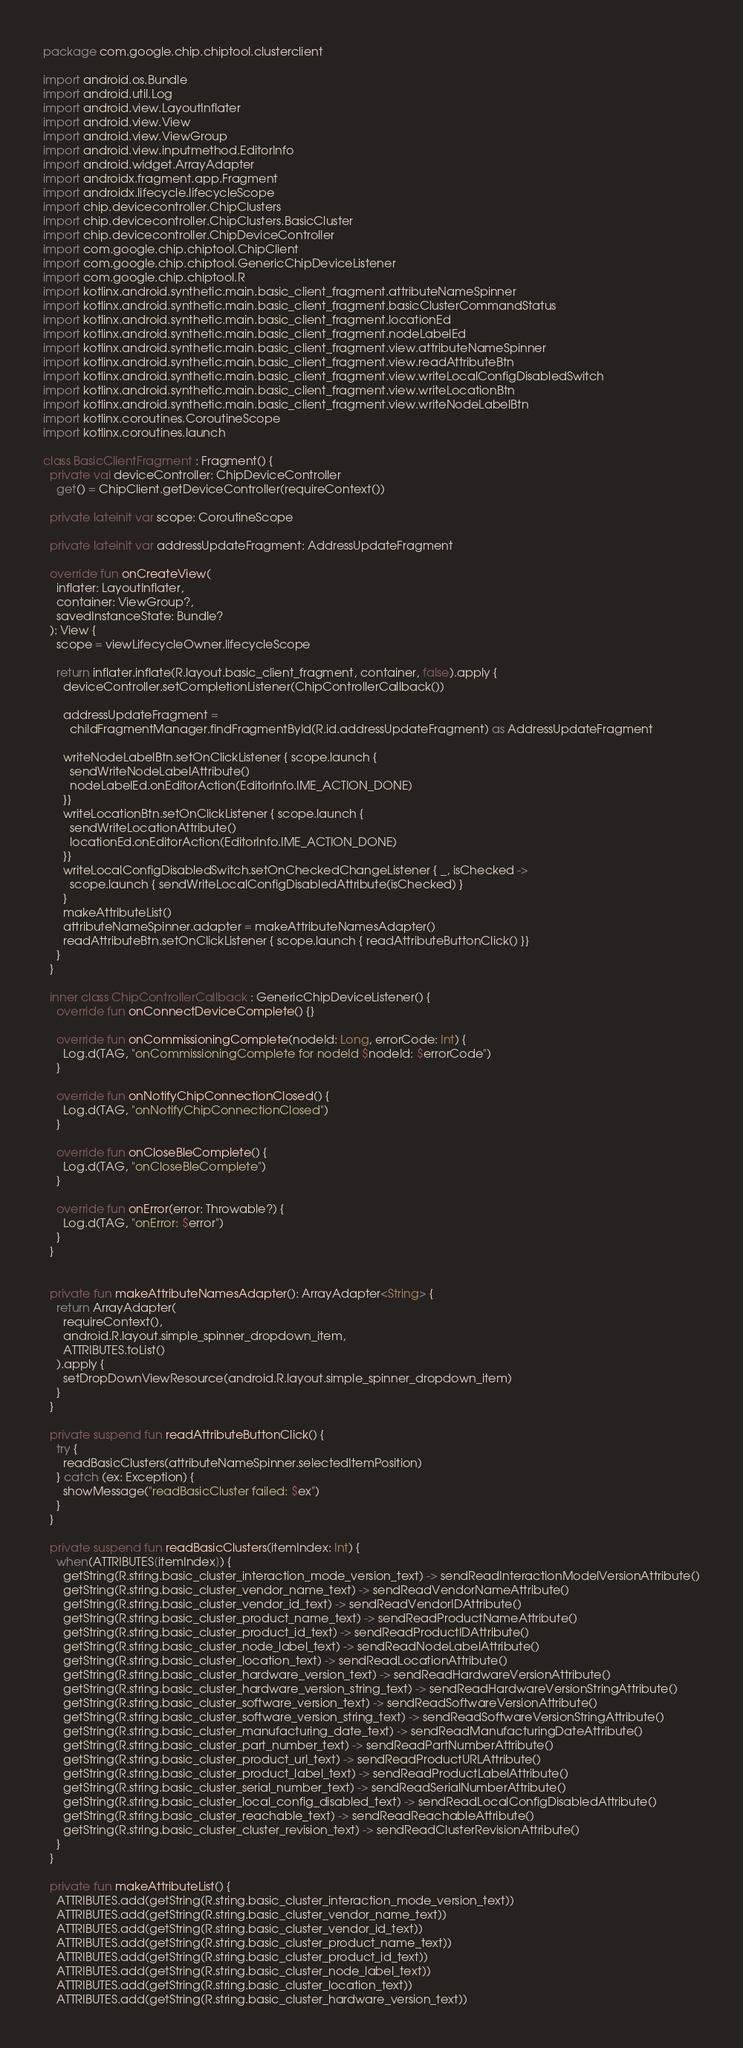<code> <loc_0><loc_0><loc_500><loc_500><_Kotlin_>package com.google.chip.chiptool.clusterclient

import android.os.Bundle
import android.util.Log
import android.view.LayoutInflater
import android.view.View
import android.view.ViewGroup
import android.view.inputmethod.EditorInfo
import android.widget.ArrayAdapter
import androidx.fragment.app.Fragment
import androidx.lifecycle.lifecycleScope
import chip.devicecontroller.ChipClusters
import chip.devicecontroller.ChipClusters.BasicCluster
import chip.devicecontroller.ChipDeviceController
import com.google.chip.chiptool.ChipClient
import com.google.chip.chiptool.GenericChipDeviceListener
import com.google.chip.chiptool.R
import kotlinx.android.synthetic.main.basic_client_fragment.attributeNameSpinner
import kotlinx.android.synthetic.main.basic_client_fragment.basicClusterCommandStatus
import kotlinx.android.synthetic.main.basic_client_fragment.locationEd
import kotlinx.android.synthetic.main.basic_client_fragment.nodeLabelEd
import kotlinx.android.synthetic.main.basic_client_fragment.view.attributeNameSpinner
import kotlinx.android.synthetic.main.basic_client_fragment.view.readAttributeBtn
import kotlinx.android.synthetic.main.basic_client_fragment.view.writeLocalConfigDisabledSwitch
import kotlinx.android.synthetic.main.basic_client_fragment.view.writeLocationBtn
import kotlinx.android.synthetic.main.basic_client_fragment.view.writeNodeLabelBtn
import kotlinx.coroutines.CoroutineScope
import kotlinx.coroutines.launch

class BasicClientFragment : Fragment() {
  private val deviceController: ChipDeviceController
    get() = ChipClient.getDeviceController(requireContext())

  private lateinit var scope: CoroutineScope

  private lateinit var addressUpdateFragment: AddressUpdateFragment

  override fun onCreateView(
    inflater: LayoutInflater,
    container: ViewGroup?,
    savedInstanceState: Bundle?
  ): View {
    scope = viewLifecycleOwner.lifecycleScope

    return inflater.inflate(R.layout.basic_client_fragment, container, false).apply {
      deviceController.setCompletionListener(ChipControllerCallback())

      addressUpdateFragment =
        childFragmentManager.findFragmentById(R.id.addressUpdateFragment) as AddressUpdateFragment

      writeNodeLabelBtn.setOnClickListener { scope.launch {
        sendWriteNodeLabelAttribute()
        nodeLabelEd.onEditorAction(EditorInfo.IME_ACTION_DONE)
      }}
      writeLocationBtn.setOnClickListener { scope.launch {
        sendWriteLocationAttribute()
        locationEd.onEditorAction(EditorInfo.IME_ACTION_DONE)
      }}
      writeLocalConfigDisabledSwitch.setOnCheckedChangeListener { _, isChecked ->
        scope.launch { sendWriteLocalConfigDisabledAttribute(isChecked) }
      }
      makeAttributeList()
      attributeNameSpinner.adapter = makeAttributeNamesAdapter()
      readAttributeBtn.setOnClickListener { scope.launch { readAttributeButtonClick() }}
    }
  }

  inner class ChipControllerCallback : GenericChipDeviceListener() {
    override fun onConnectDeviceComplete() {}

    override fun onCommissioningComplete(nodeId: Long, errorCode: Int) {
      Log.d(TAG, "onCommissioningComplete for nodeId $nodeId: $errorCode")
    }

    override fun onNotifyChipConnectionClosed() {
      Log.d(TAG, "onNotifyChipConnectionClosed")
    }

    override fun onCloseBleComplete() {
      Log.d(TAG, "onCloseBleComplete")
    }

    override fun onError(error: Throwable?) {
      Log.d(TAG, "onError: $error")
    }
  }


  private fun makeAttributeNamesAdapter(): ArrayAdapter<String> {
    return ArrayAdapter(
      requireContext(),
      android.R.layout.simple_spinner_dropdown_item,
      ATTRIBUTES.toList()
    ).apply {
      setDropDownViewResource(android.R.layout.simple_spinner_dropdown_item)
    }
  }

  private suspend fun readAttributeButtonClick() {
    try {
      readBasicClusters(attributeNameSpinner.selectedItemPosition)
    } catch (ex: Exception) {
      showMessage("readBasicCluster failed: $ex")
    }
  }

  private suspend fun readBasicClusters(itemIndex: Int) {
    when(ATTRIBUTES[itemIndex]) {
      getString(R.string.basic_cluster_interaction_mode_version_text) -> sendReadInteractionModelVersionAttribute()
      getString(R.string.basic_cluster_vendor_name_text) -> sendReadVendorNameAttribute()
      getString(R.string.basic_cluster_vendor_id_text) -> sendReadVendorIDAttribute()
      getString(R.string.basic_cluster_product_name_text) -> sendReadProductNameAttribute()
      getString(R.string.basic_cluster_product_id_text) -> sendReadProductIDAttribute()
      getString(R.string.basic_cluster_node_label_text) -> sendReadNodeLabelAttribute()
      getString(R.string.basic_cluster_location_text) -> sendReadLocationAttribute()
      getString(R.string.basic_cluster_hardware_version_text) -> sendReadHardwareVersionAttribute()
      getString(R.string.basic_cluster_hardware_version_string_text) -> sendReadHardwareVersionStringAttribute()
      getString(R.string.basic_cluster_software_version_text) -> sendReadSoftwareVersionAttribute()
      getString(R.string.basic_cluster_software_version_string_text) -> sendReadSoftwareVersionStringAttribute()
      getString(R.string.basic_cluster_manufacturing_date_text) -> sendReadManufacturingDateAttribute()
      getString(R.string.basic_cluster_part_number_text) -> sendReadPartNumberAttribute()
      getString(R.string.basic_cluster_product_url_text) -> sendReadProductURLAttribute()
      getString(R.string.basic_cluster_product_label_text) -> sendReadProductLabelAttribute()
      getString(R.string.basic_cluster_serial_number_text) -> sendReadSerialNumberAttribute()
      getString(R.string.basic_cluster_local_config_disabled_text) -> sendReadLocalConfigDisabledAttribute()
      getString(R.string.basic_cluster_reachable_text) -> sendReadReachableAttribute()
      getString(R.string.basic_cluster_cluster_revision_text) -> sendReadClusterRevisionAttribute()
    }
  }

  private fun makeAttributeList() {
    ATTRIBUTES.add(getString(R.string.basic_cluster_interaction_mode_version_text))
    ATTRIBUTES.add(getString(R.string.basic_cluster_vendor_name_text))
    ATTRIBUTES.add(getString(R.string.basic_cluster_vendor_id_text))
    ATTRIBUTES.add(getString(R.string.basic_cluster_product_name_text))
    ATTRIBUTES.add(getString(R.string.basic_cluster_product_id_text))
    ATTRIBUTES.add(getString(R.string.basic_cluster_node_label_text))
    ATTRIBUTES.add(getString(R.string.basic_cluster_location_text))
    ATTRIBUTES.add(getString(R.string.basic_cluster_hardware_version_text))</code> 